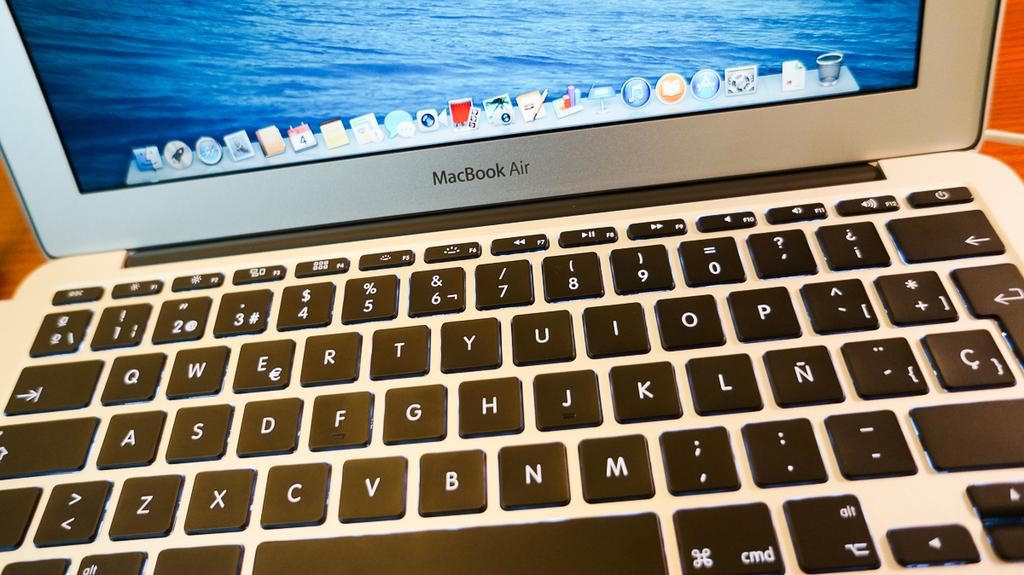What electronic device is visible in the image? There is a laptop in the image. What is displayed on the screen of the laptop? There is text on the screen of the laptop. What type of input device is present in the image? There are keyboards with text and numbers in the image. Can you see any volleyball players in the image? There are no volleyball players present in the image. What type of drink is being served in the image? There is no drink mentioned or depicted in the image. 